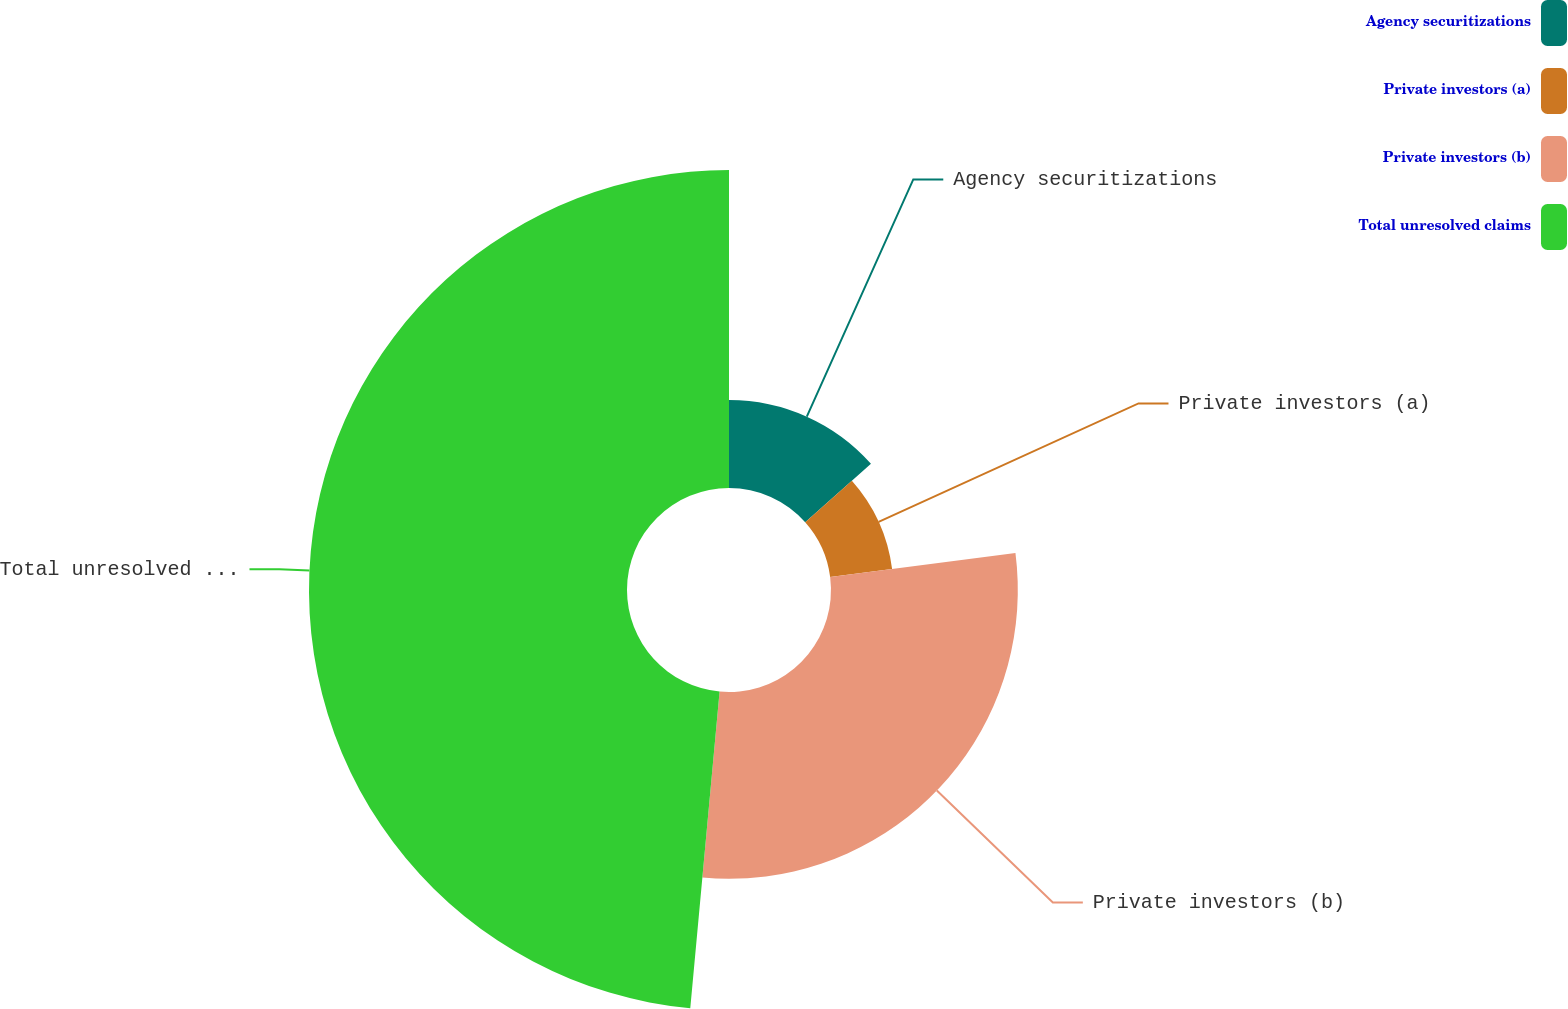<chart> <loc_0><loc_0><loc_500><loc_500><pie_chart><fcel>Agency securitizations<fcel>Private investors (a)<fcel>Private investors (b)<fcel>Total unresolved claims<nl><fcel>13.43%<fcel>9.53%<fcel>28.51%<fcel>48.53%<nl></chart> 